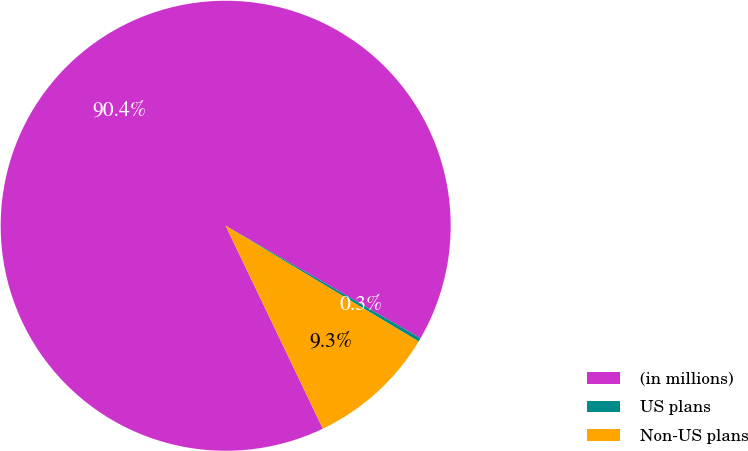Convert chart. <chart><loc_0><loc_0><loc_500><loc_500><pie_chart><fcel>(in millions)<fcel>US plans<fcel>Non-US plans<nl><fcel>90.44%<fcel>0.27%<fcel>9.29%<nl></chart> 